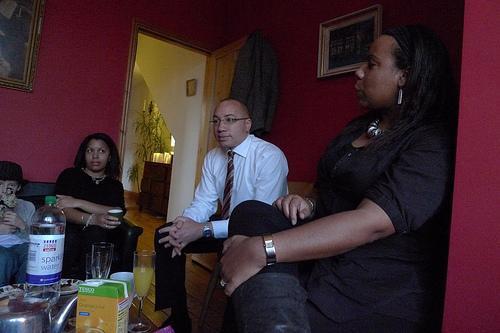How many people are wearing glasses?
Give a very brief answer. 1. How many people are there?
Give a very brief answer. 4. 